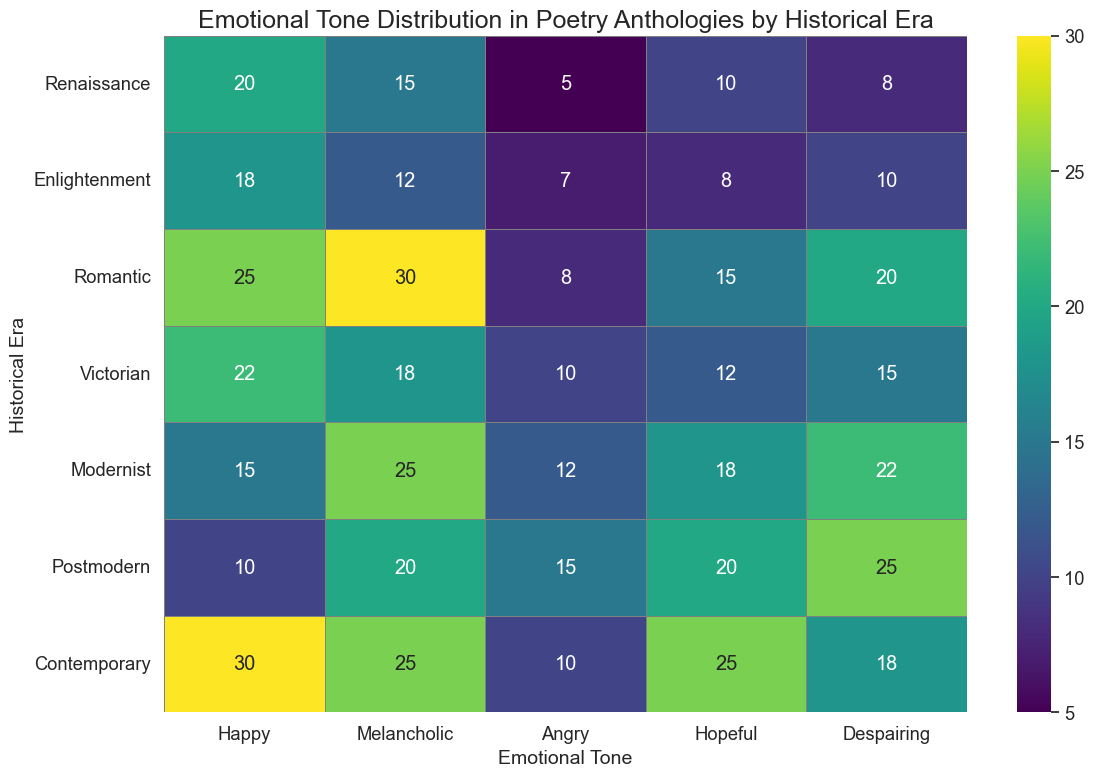what is the highest count of the Melancholic tone and in which era does it occur? To determine this, we look across all the values in the Melancholic column. The highest value is 30 which occurs in the Romantic era.
Answer: 30, Romantic era Which historical era has the lowest count for the Angry tone? Review each era's Angry tone count and identify the smallest number. The lowest count of 5 is in the Renaissance era.
Answer: Renaissance era What is the total count of the Happy tone across all eras? Add all the counts in the Happy column: 20 + 18 + 25 + 22 + 15 + 10 + 30 = 140.
Answer: 140 Is there a historical era where the Despairing tone count is greater than the Hopeful tone count? By comparing the Despairing and Hopeful counts for each era:
- Renaissance: Despairing (8) < Hopeful (10)
- Enlightenment: Despairing (10) > Hopeful (8)
- Romantic: Despairing (20) > Hopeful (15)
- Victorian: Despairing (15) > Hopeful (12)
- Modernist: Despairing (22) > Hopeful (18)
- Postmodern: Despairing (25) > Hopeful (20)
- Contemporary: Despairing (18) < Hopeful (25)
Thus, in five eras (Enlightenment, Romantic, Victorian, Modernist, Postmodern), the Despairing tone count is greater than the Hopeful tone count.
Answer: Yes, in five eras Which emotional tone has the highest count in the Contemporary era and what is that count? Review the counts for each tone in the Contemporary era row. The highest count is 30 for the Happy tone.
Answer: Happy, 30 What is the difference between the highest and lowest counts of the Hopeful tone across all eras? Identify the highest and lowest counts in the Hopeful column: highest is 25 (Contemporary), lowest is 8 (Enlightenment). Calculate the difference: 25 - 8 = 17.
Answer: 17 Is the Melancholic tone more prevalent in the Modernist era compared to the Victorian era? Compare the Melancholic tone counts for Modernist (25) and Victorian (18). Modernist has a higher count.
Answer: Yes Which era has the darkest shade for the Despairing tone and what does that shade represent? The darkest shade corresponds to the highest count. For the Despairing tone, the highest count is 25 in the Postmodern era.
Answer: Postmodern, 25 How many emotional tones in the Romantic era have a count of 20 or more? Count the number of emotional tones in the Romantic era row with values 20 or more: Happy (25), Melancholic (30), and Despairing (20). There are three such tones.
Answer: 3 What is the average count of the Hopeful tone across all historical eras? Compute the average by summing the Hopeful counts and dividing by the number of eras: (10 + 8 + 15 + 12 + 18 + 20 + 25) / 7 = 108 / 7 ≈ 15.43.
Answer: ~15.43 